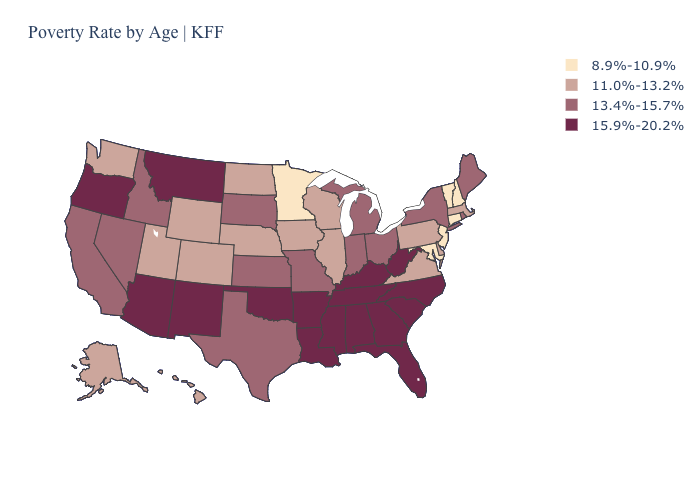Does the map have missing data?
Keep it brief. No. Which states hav the highest value in the West?
Keep it brief. Arizona, Montana, New Mexico, Oregon. Which states have the highest value in the USA?
Keep it brief. Alabama, Arizona, Arkansas, Florida, Georgia, Kentucky, Louisiana, Mississippi, Montana, New Mexico, North Carolina, Oklahoma, Oregon, South Carolina, Tennessee, West Virginia. Does the first symbol in the legend represent the smallest category?
Give a very brief answer. Yes. What is the lowest value in the USA?
Keep it brief. 8.9%-10.9%. How many symbols are there in the legend?
Concise answer only. 4. Does Colorado have a lower value than Iowa?
Give a very brief answer. No. Among the states that border Texas , which have the highest value?
Keep it brief. Arkansas, Louisiana, New Mexico, Oklahoma. Is the legend a continuous bar?
Write a very short answer. No. What is the highest value in the South ?
Give a very brief answer. 15.9%-20.2%. Name the states that have a value in the range 13.4%-15.7%?
Give a very brief answer. California, Idaho, Indiana, Kansas, Maine, Michigan, Missouri, Nevada, New York, Ohio, Rhode Island, South Dakota, Texas. Name the states that have a value in the range 15.9%-20.2%?
Give a very brief answer. Alabama, Arizona, Arkansas, Florida, Georgia, Kentucky, Louisiana, Mississippi, Montana, New Mexico, North Carolina, Oklahoma, Oregon, South Carolina, Tennessee, West Virginia. Among the states that border North Carolina , does Virginia have the lowest value?
Concise answer only. Yes. Which states have the lowest value in the USA?
Short answer required. Connecticut, Maryland, Minnesota, New Hampshire, New Jersey, Vermont. 